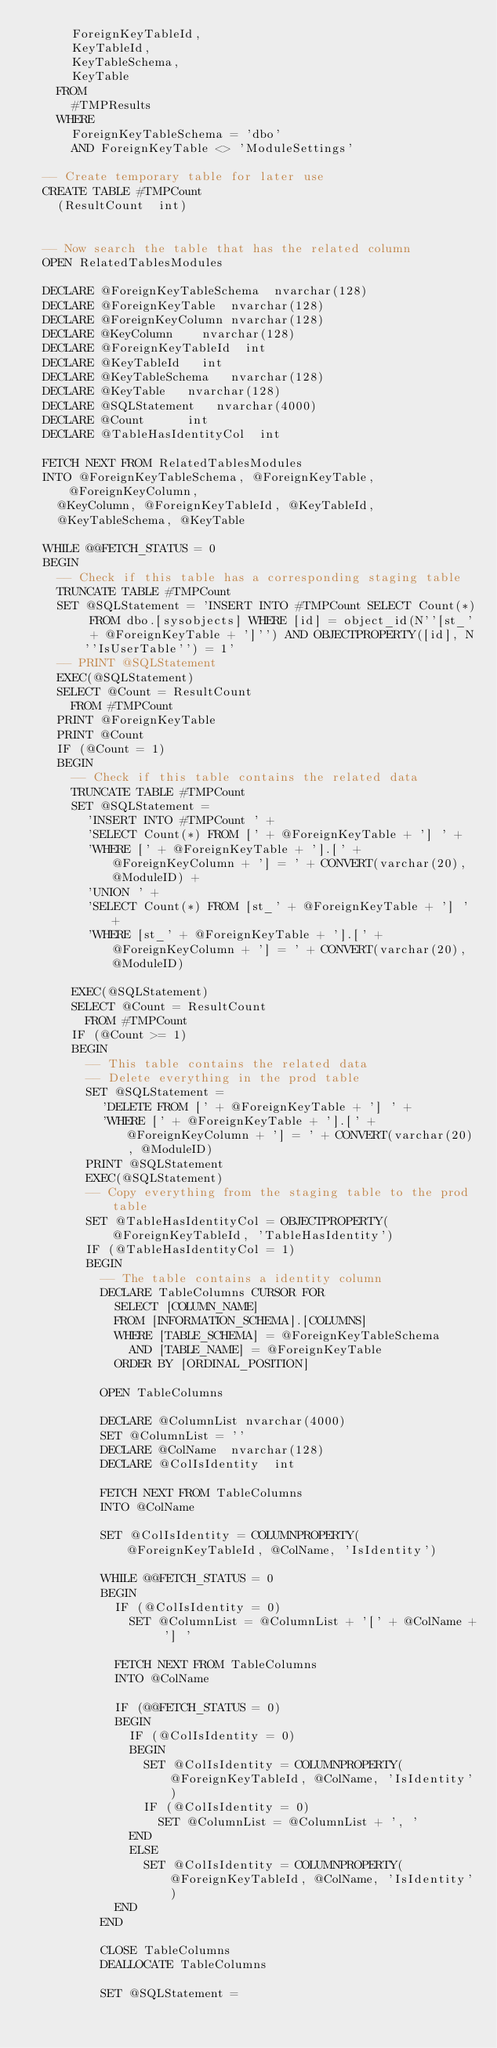<code> <loc_0><loc_0><loc_500><loc_500><_SQL_>			ForeignKeyTableId,
			KeyTableId,
			KeyTableSchema,
			KeyTable
		FROM
			#TMPResults
		WHERE 
			ForeignKeyTableSchema = 'dbo'
			AND ForeignKeyTable <> 'ModuleSettings'

	-- Create temporary table for later use
	CREATE TABLE #TMPCount
		(ResultCount	int)


	-- Now search the table that has the related column
	OPEN RelatedTablesModules

	DECLARE @ForeignKeyTableSchema 	nvarchar(128)
	DECLARE @ForeignKeyTable	nvarchar(128)
	DECLARE @ForeignKeyColumn	nvarchar(128)
	DECLARE @KeyColumn		nvarchar(128)
	DECLARE @ForeignKeyTableId	int
	DECLARE @KeyTableId		int
	DECLARE @KeyTableSchema		nvarchar(128)
	DECLARE @KeyTable		nvarchar(128)
	DECLARE @SQLStatement		nvarchar(4000)
	DECLARE @Count			int
	DECLARE @TableHasIdentityCol	int

	FETCH NEXT FROM RelatedTablesModules 
	INTO @ForeignKeyTableSchema, @ForeignKeyTable, @ForeignKeyColumn, 
		@KeyColumn, @ForeignKeyTableId, @KeyTableId,
		@KeyTableSchema, @KeyTable
	
	WHILE @@FETCH_STATUS = 0
	BEGIN
		-- Check if this table has a corresponding staging table
		TRUNCATE TABLE #TMPCount
		SET @SQLStatement = 'INSERT INTO #TMPCount SELECT Count(*) FROM dbo.[sysobjects] WHERE [id] = object_id(N''[st_' + @ForeignKeyTable + ']'') AND OBJECTPROPERTY([id], N''IsUserTable'') = 1'
		-- PRINT @SQLStatement
		EXEC(@SQLStatement)
		SELECT @Count = ResultCount
			FROM #TMPCount		
		PRINT @ForeignKeyTable
		PRINT @Count
		IF (@Count = 1)
		BEGIN						
			-- Check if this table contains the related data
			TRUNCATE TABLE #TMPCount
			SET @SQLStatement = 
				'INSERT INTO #TMPCount ' +
				'SELECT Count(*) FROM [' + @ForeignKeyTable + '] ' +
				'WHERE [' + @ForeignKeyTable + '].[' + @ForeignKeyColumn + '] = ' + CONVERT(varchar(20), @ModuleID) +
				'UNION ' +
				'SELECT Count(*) FROM [st_' + @ForeignKeyTable + '] ' +
				'WHERE [st_' + @ForeignKeyTable + '].[' + @ForeignKeyColumn + '] = ' + CONVERT(varchar(20), @ModuleID) 

			EXEC(@SQLStatement)
			SELECT @Count = ResultCount
				FROM #TMPCount		
			IF (@Count >= 1) 
			BEGIN
				-- This table contains the related data 
				-- Delete everything in the prod table
				SET @SQLStatement = 
					'DELETE FROM [' + @ForeignKeyTable + '] ' +
					'WHERE [' + @ForeignKeyTable + '].[' + @ForeignKeyColumn + '] = ' + CONVERT(varchar(20), @ModuleID)
				PRINT @SQLStatement
				EXEC(@SQLStatement)
				-- Copy everything from the staging table to the prod table
				SET @TableHasIdentityCol = OBJECTPROPERTY(@ForeignKeyTableId, 'TableHasIdentity')
				IF (@TableHasIdentityCol = 1)
				BEGIN
					-- The table contains a identity column
					DECLARE TableColumns CURSOR FOR
						SELECT [COLUMN_NAME]
						FROM [INFORMATION_SCHEMA].[COLUMNS]
						WHERE [TABLE_SCHEMA] = @ForeignKeyTableSchema 
							AND [TABLE_NAME] = @ForeignKeyTable
						ORDER BY [ORDINAL_POSITION]
	
					OPEN TableColumns
	
					DECLARE @ColumnList	nvarchar(4000)
					SET @ColumnList = ''
					DECLARE @ColName	nvarchar(128)
					DECLARE @ColIsIdentity	int
	
					FETCH NEXT FROM TableColumns
					INTO @ColName
					
					SET @ColIsIdentity = COLUMNPROPERTY(@ForeignKeyTableId, @ColName, 'IsIdentity')
	
					WHILE @@FETCH_STATUS = 0
					BEGIN
						IF (@ColIsIdentity = 0)
							SET @ColumnList = @ColumnList + '[' + @ColName + '] '
	
						FETCH NEXT FROM TableColumns
						INTO @ColName
	
						IF (@@FETCH_STATUS = 0)
						BEGIN
							IF (@ColIsIdentity = 0)
							BEGIN
								SET @ColIsIdentity = COLUMNPROPERTY(@ForeignKeyTableId, @ColName, 'IsIdentity')
								IF (@ColIsIdentity = 0)
									SET @ColumnList = @ColumnList + ', '		
							END
							ELSE
								SET @ColIsIdentity = COLUMNPROPERTY(@ForeignKeyTableId, @ColName, 'IsIdentity')
						END
					END
					
					CLOSE TableColumns
					DEALLOCATE TableColumns		
	
					SET @SQLStatement = 	</code> 